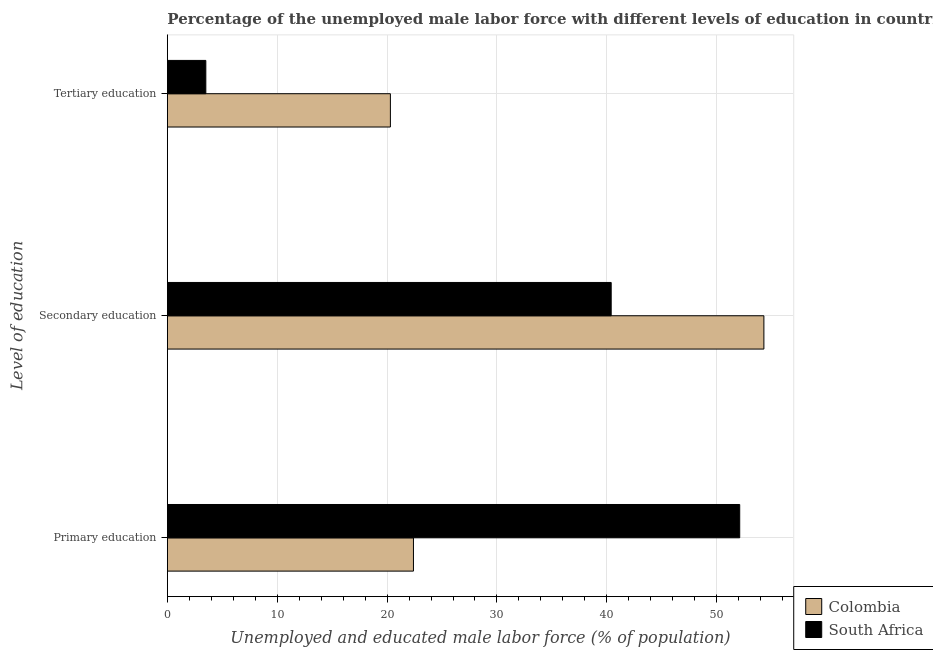Are the number of bars on each tick of the Y-axis equal?
Offer a terse response. Yes. How many bars are there on the 1st tick from the top?
Ensure brevity in your answer.  2. What is the label of the 1st group of bars from the top?
Give a very brief answer. Tertiary education. What is the percentage of male labor force who received secondary education in Colombia?
Make the answer very short. 54.3. Across all countries, what is the maximum percentage of male labor force who received primary education?
Provide a succinct answer. 52.1. In which country was the percentage of male labor force who received primary education maximum?
Ensure brevity in your answer.  South Africa. In which country was the percentage of male labor force who received primary education minimum?
Your answer should be compact. Colombia. What is the total percentage of male labor force who received secondary education in the graph?
Provide a succinct answer. 94.7. What is the difference between the percentage of male labor force who received tertiary education in South Africa and that in Colombia?
Ensure brevity in your answer.  -16.8. What is the difference between the percentage of male labor force who received primary education in South Africa and the percentage of male labor force who received tertiary education in Colombia?
Offer a very short reply. 31.8. What is the average percentage of male labor force who received secondary education per country?
Your response must be concise. 47.35. What is the difference between the percentage of male labor force who received tertiary education and percentage of male labor force who received primary education in Colombia?
Give a very brief answer. -2.1. In how many countries, is the percentage of male labor force who received secondary education greater than 8 %?
Ensure brevity in your answer.  2. What is the ratio of the percentage of male labor force who received primary education in Colombia to that in South Africa?
Ensure brevity in your answer.  0.43. Is the difference between the percentage of male labor force who received tertiary education in Colombia and South Africa greater than the difference between the percentage of male labor force who received secondary education in Colombia and South Africa?
Provide a succinct answer. Yes. What is the difference between the highest and the second highest percentage of male labor force who received tertiary education?
Your answer should be compact. 16.8. What is the difference between the highest and the lowest percentage of male labor force who received tertiary education?
Make the answer very short. 16.8. What does the 1st bar from the top in Primary education represents?
Give a very brief answer. South Africa. Is it the case that in every country, the sum of the percentage of male labor force who received primary education and percentage of male labor force who received secondary education is greater than the percentage of male labor force who received tertiary education?
Provide a short and direct response. Yes. How many bars are there?
Provide a short and direct response. 6. Are all the bars in the graph horizontal?
Provide a short and direct response. Yes. How many countries are there in the graph?
Offer a very short reply. 2. Does the graph contain any zero values?
Your answer should be compact. No. Where does the legend appear in the graph?
Ensure brevity in your answer.  Bottom right. How many legend labels are there?
Ensure brevity in your answer.  2. How are the legend labels stacked?
Make the answer very short. Vertical. What is the title of the graph?
Offer a terse response. Percentage of the unemployed male labor force with different levels of education in countries. What is the label or title of the X-axis?
Offer a terse response. Unemployed and educated male labor force (% of population). What is the label or title of the Y-axis?
Give a very brief answer. Level of education. What is the Unemployed and educated male labor force (% of population) in Colombia in Primary education?
Ensure brevity in your answer.  22.4. What is the Unemployed and educated male labor force (% of population) of South Africa in Primary education?
Your response must be concise. 52.1. What is the Unemployed and educated male labor force (% of population) of Colombia in Secondary education?
Offer a terse response. 54.3. What is the Unemployed and educated male labor force (% of population) in South Africa in Secondary education?
Your answer should be very brief. 40.4. What is the Unemployed and educated male labor force (% of population) in Colombia in Tertiary education?
Provide a succinct answer. 20.3. What is the Unemployed and educated male labor force (% of population) in South Africa in Tertiary education?
Your response must be concise. 3.5. Across all Level of education, what is the maximum Unemployed and educated male labor force (% of population) in Colombia?
Provide a succinct answer. 54.3. Across all Level of education, what is the maximum Unemployed and educated male labor force (% of population) of South Africa?
Make the answer very short. 52.1. Across all Level of education, what is the minimum Unemployed and educated male labor force (% of population) of Colombia?
Ensure brevity in your answer.  20.3. What is the total Unemployed and educated male labor force (% of population) of Colombia in the graph?
Your answer should be compact. 97. What is the total Unemployed and educated male labor force (% of population) of South Africa in the graph?
Offer a very short reply. 96. What is the difference between the Unemployed and educated male labor force (% of population) of Colombia in Primary education and that in Secondary education?
Your answer should be compact. -31.9. What is the difference between the Unemployed and educated male labor force (% of population) in South Africa in Primary education and that in Secondary education?
Give a very brief answer. 11.7. What is the difference between the Unemployed and educated male labor force (% of population) of Colombia in Primary education and that in Tertiary education?
Your answer should be very brief. 2.1. What is the difference between the Unemployed and educated male labor force (% of population) of South Africa in Primary education and that in Tertiary education?
Provide a short and direct response. 48.6. What is the difference between the Unemployed and educated male labor force (% of population) in Colombia in Secondary education and that in Tertiary education?
Make the answer very short. 34. What is the difference between the Unemployed and educated male labor force (% of population) of South Africa in Secondary education and that in Tertiary education?
Offer a very short reply. 36.9. What is the difference between the Unemployed and educated male labor force (% of population) in Colombia in Primary education and the Unemployed and educated male labor force (% of population) in South Africa in Tertiary education?
Your answer should be compact. 18.9. What is the difference between the Unemployed and educated male labor force (% of population) of Colombia in Secondary education and the Unemployed and educated male labor force (% of population) of South Africa in Tertiary education?
Keep it short and to the point. 50.8. What is the average Unemployed and educated male labor force (% of population) of Colombia per Level of education?
Offer a terse response. 32.33. What is the difference between the Unemployed and educated male labor force (% of population) in Colombia and Unemployed and educated male labor force (% of population) in South Africa in Primary education?
Give a very brief answer. -29.7. What is the ratio of the Unemployed and educated male labor force (% of population) in Colombia in Primary education to that in Secondary education?
Give a very brief answer. 0.41. What is the ratio of the Unemployed and educated male labor force (% of population) in South Africa in Primary education to that in Secondary education?
Your response must be concise. 1.29. What is the ratio of the Unemployed and educated male labor force (% of population) of Colombia in Primary education to that in Tertiary education?
Make the answer very short. 1.1. What is the ratio of the Unemployed and educated male labor force (% of population) in South Africa in Primary education to that in Tertiary education?
Make the answer very short. 14.89. What is the ratio of the Unemployed and educated male labor force (% of population) of Colombia in Secondary education to that in Tertiary education?
Your answer should be very brief. 2.67. What is the ratio of the Unemployed and educated male labor force (% of population) of South Africa in Secondary education to that in Tertiary education?
Your response must be concise. 11.54. What is the difference between the highest and the second highest Unemployed and educated male labor force (% of population) in Colombia?
Provide a short and direct response. 31.9. What is the difference between the highest and the lowest Unemployed and educated male labor force (% of population) of South Africa?
Make the answer very short. 48.6. 